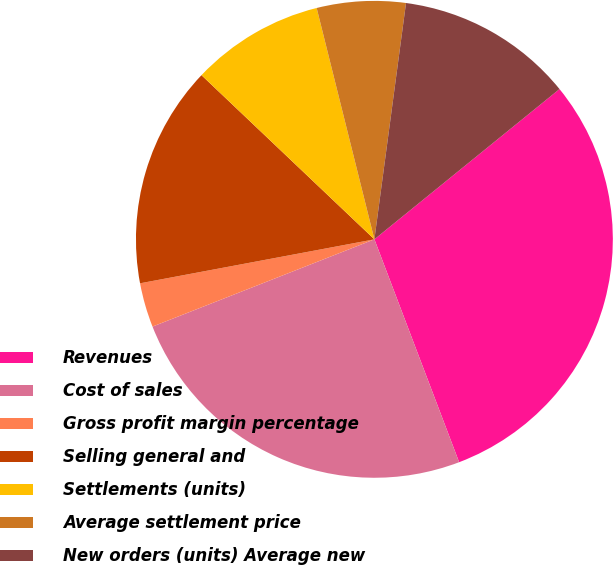Convert chart to OTSL. <chart><loc_0><loc_0><loc_500><loc_500><pie_chart><fcel>Revenues<fcel>Cost of sales<fcel>Gross profit margin percentage<fcel>Selling general and<fcel>Settlements (units)<fcel>Average settlement price<fcel>New orders (units) Average new<fcel>Average backlog price New<nl><fcel>30.07%<fcel>24.82%<fcel>3.01%<fcel>15.04%<fcel>9.02%<fcel>6.01%<fcel>12.03%<fcel>0.0%<nl></chart> 